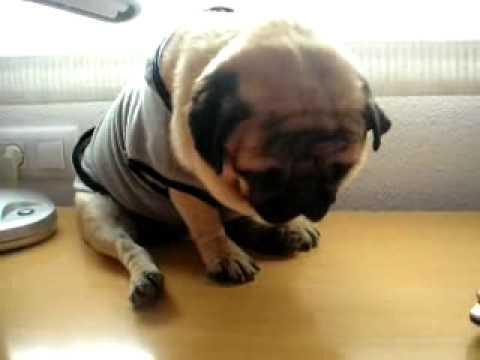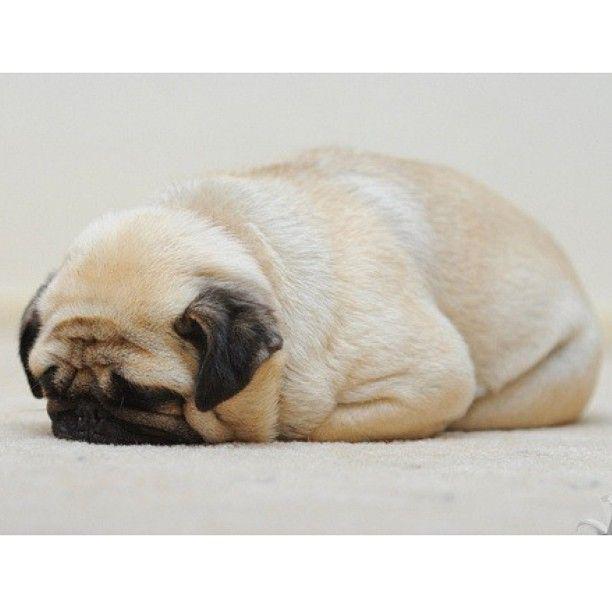The first image is the image on the left, the second image is the image on the right. Considering the images on both sides, is "Not one of the dogs is laying on a sofa." valid? Answer yes or no. Yes. The first image is the image on the left, the second image is the image on the right. For the images shown, is this caption "Each image shows one dog lounging on a soft cushioned surface." true? Answer yes or no. No. 